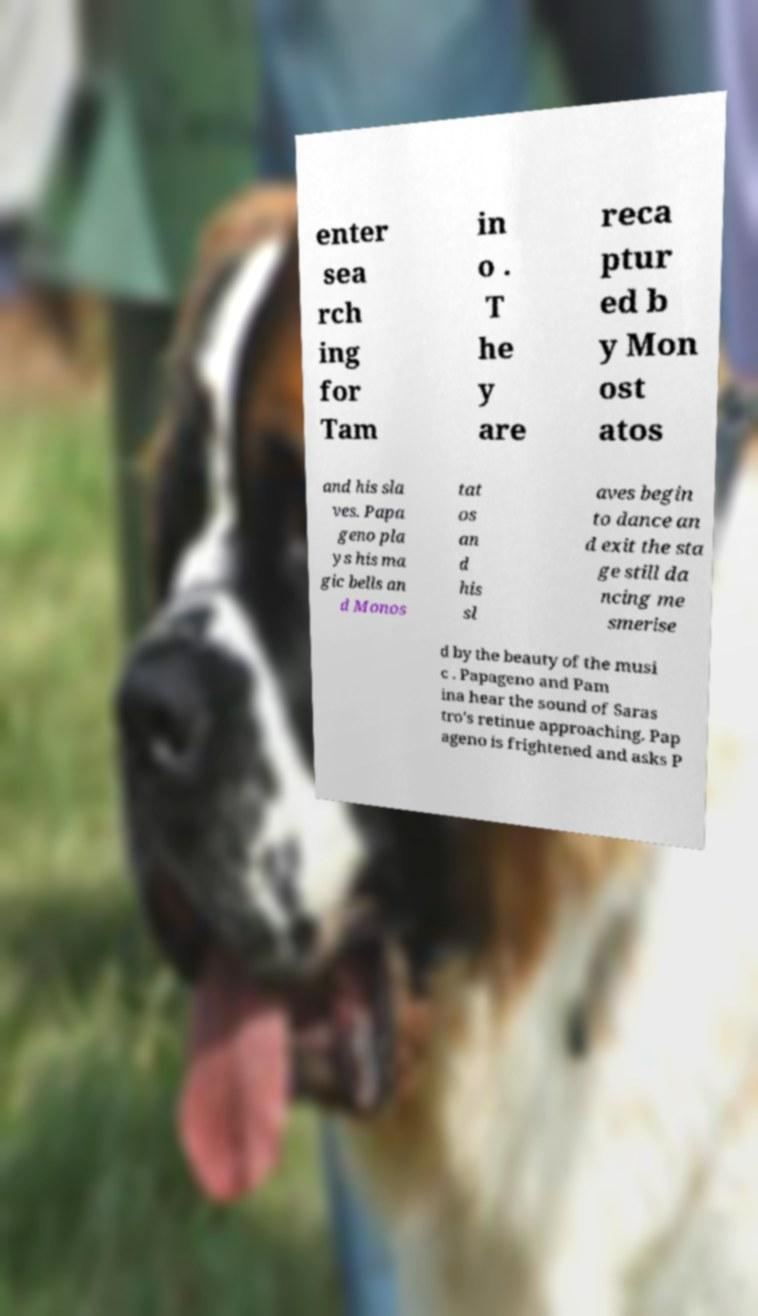There's text embedded in this image that I need extracted. Can you transcribe it verbatim? enter sea rch ing for Tam in o . T he y are reca ptur ed b y Mon ost atos and his sla ves. Papa geno pla ys his ma gic bells an d Monos tat os an d his sl aves begin to dance an d exit the sta ge still da ncing me smerise d by the beauty of the musi c . Papageno and Pam ina hear the sound of Saras tro's retinue approaching. Pap ageno is frightened and asks P 